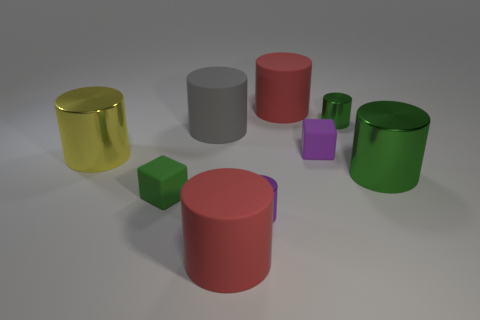Which objects in the image could hold more liquid, the yellow or the green cylinder? From their relative sizes visible in the image, it appears that the green cylinder would be able to hold more liquid than the yellow cylinder, as it is both taller and wider. 